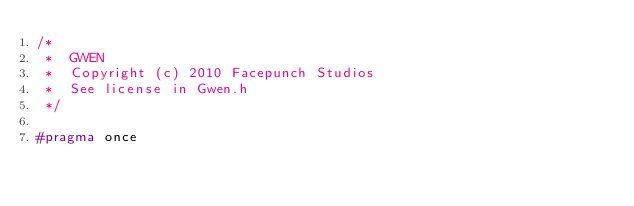Convert code to text. <code><loc_0><loc_0><loc_500><loc_500><_C_>/*
 *  GWEN
 *  Copyright (c) 2010 Facepunch Studios
 *  See license in Gwen.h
 */

#pragma once</code> 